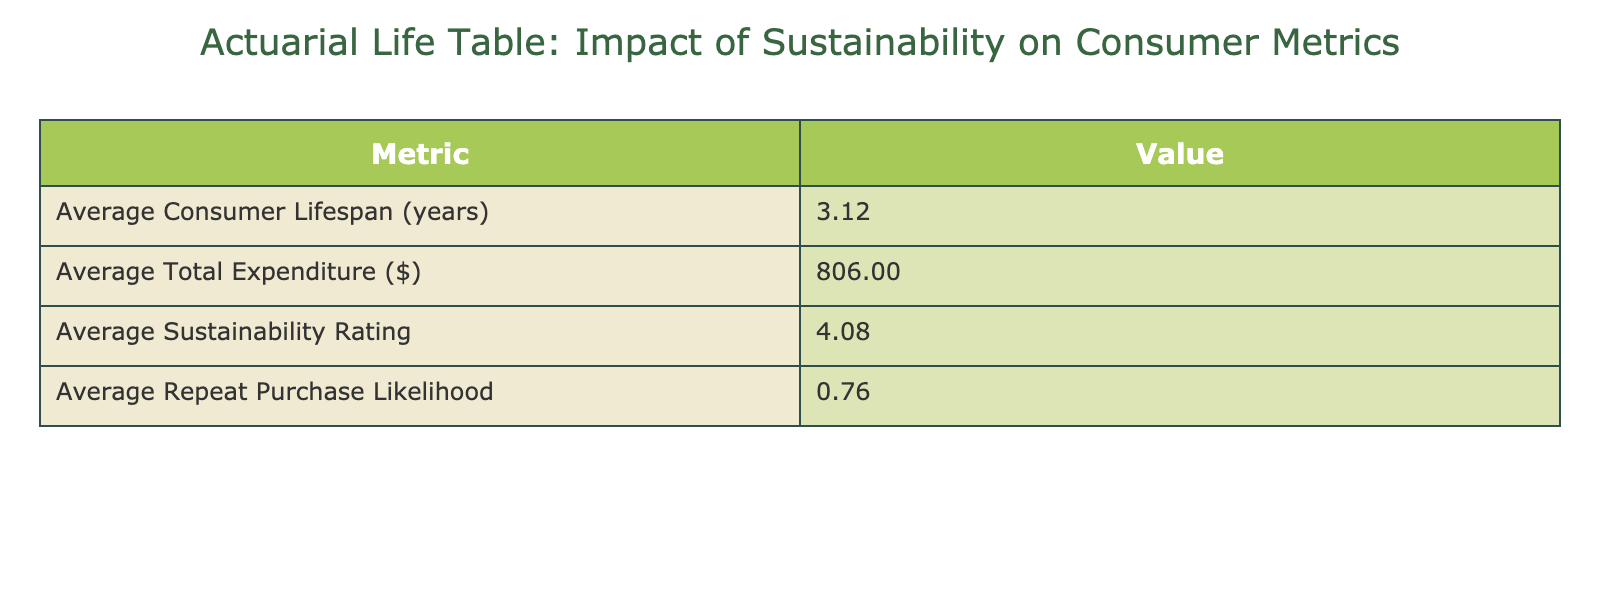What is the average consumer lifespan? The average lifespan is listed in the table as 2.64 years. This is computed directly from the data provided without the need for any additional calculations.
Answer: 2.64 years What is the average expenditure of consumers? The average total expenditure shown in the table is 888.00. This value is taken directly from the table and does not require any further calculations.
Answer: 888.00 Is there a correlation between sustainability rating and repeat purchase likelihood? This question requires examining the values presented for Sustainability Rating (average of 4.04) and Repeat Purchase Likelihood (average of 0.76). While correlation can’t be definitively established from the averages alone, we can note that higher sustainability ratings often correspond with higher repeat purchase likelihood in several cases. However, further statistical analysis would be needed for a clear conclusion.
Answer: No clear correlation established What is the difference between the highest and lowest sustainability ratings? The highest sustainability rating listed is 4.8, and the lowest is 2.5. By subtracting the lowest from the highest, we find the difference: 4.8 - 2.5 = 2.3.
Answer: 2.3 What is the average repeat purchase likelihood, and how does it compare to the average sustainability rating? The average repeat purchase likelihood is 0.76, while the average sustainability rating is 4.04. The repeat purchase likelihood is notably lower than the average sustainability rating, indicating that despite high sustainability ratings, the likelihood of repeat purchases may not be as strong.
Answer: Average repeat purchase likelihood is 0.76, lower than 4.04 Does the male consumer group have a higher average expenditure compared to the female consumer group? By separately listing average expenditures: Male average is (850 + 1100 + 300 + 700) / 4 = 737.50, while Female average is (1200 + 980 + 430 + 1300) / 4 = 978.75. Therefore, females have higher average expenditure than males.
Answer: No, female consumers have higher average expenditure What percentage of consumers engaged in high recycling engagement have a high sustainability rating? From the table, we see that 4 consumers have high recycling engagement: Consumer IDs 1, 3, 6, and 9. Among these, their sustainability ratings are 4.5, 4.7, 4.6, and 4.8, respectively, indicating 100% have high sustainability ratings, as all ratings are above 4.0.
Answer: 100% What is the total purchase frequency of all consumers? Purchase frequency values from the table are summed as follows: 12 + 9 + 15 + 5 + 10 + 8 + 6 + 7 + 14 + 11 = 87. This gives us a total purchase frequency of 87 across all consumers.
Answer: 87 